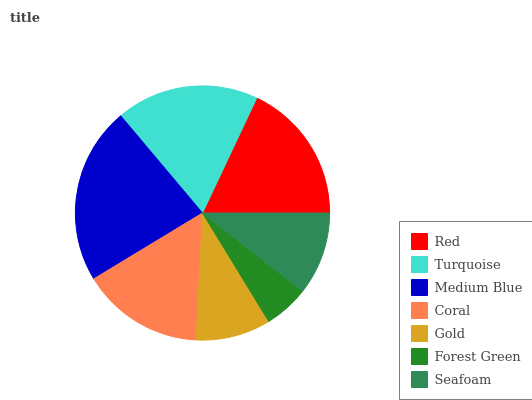Is Forest Green the minimum?
Answer yes or no. Yes. Is Medium Blue the maximum?
Answer yes or no. Yes. Is Turquoise the minimum?
Answer yes or no. No. Is Turquoise the maximum?
Answer yes or no. No. Is Turquoise greater than Red?
Answer yes or no. Yes. Is Red less than Turquoise?
Answer yes or no. Yes. Is Red greater than Turquoise?
Answer yes or no. No. Is Turquoise less than Red?
Answer yes or no. No. Is Coral the high median?
Answer yes or no. Yes. Is Coral the low median?
Answer yes or no. Yes. Is Red the high median?
Answer yes or no. No. Is Seafoam the low median?
Answer yes or no. No. 